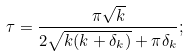<formula> <loc_0><loc_0><loc_500><loc_500>\tau = \frac { \pi \sqrt { k } } { 2 \sqrt { k ( k + \delta _ { k } ) } + \pi \delta _ { k } } ;</formula> 